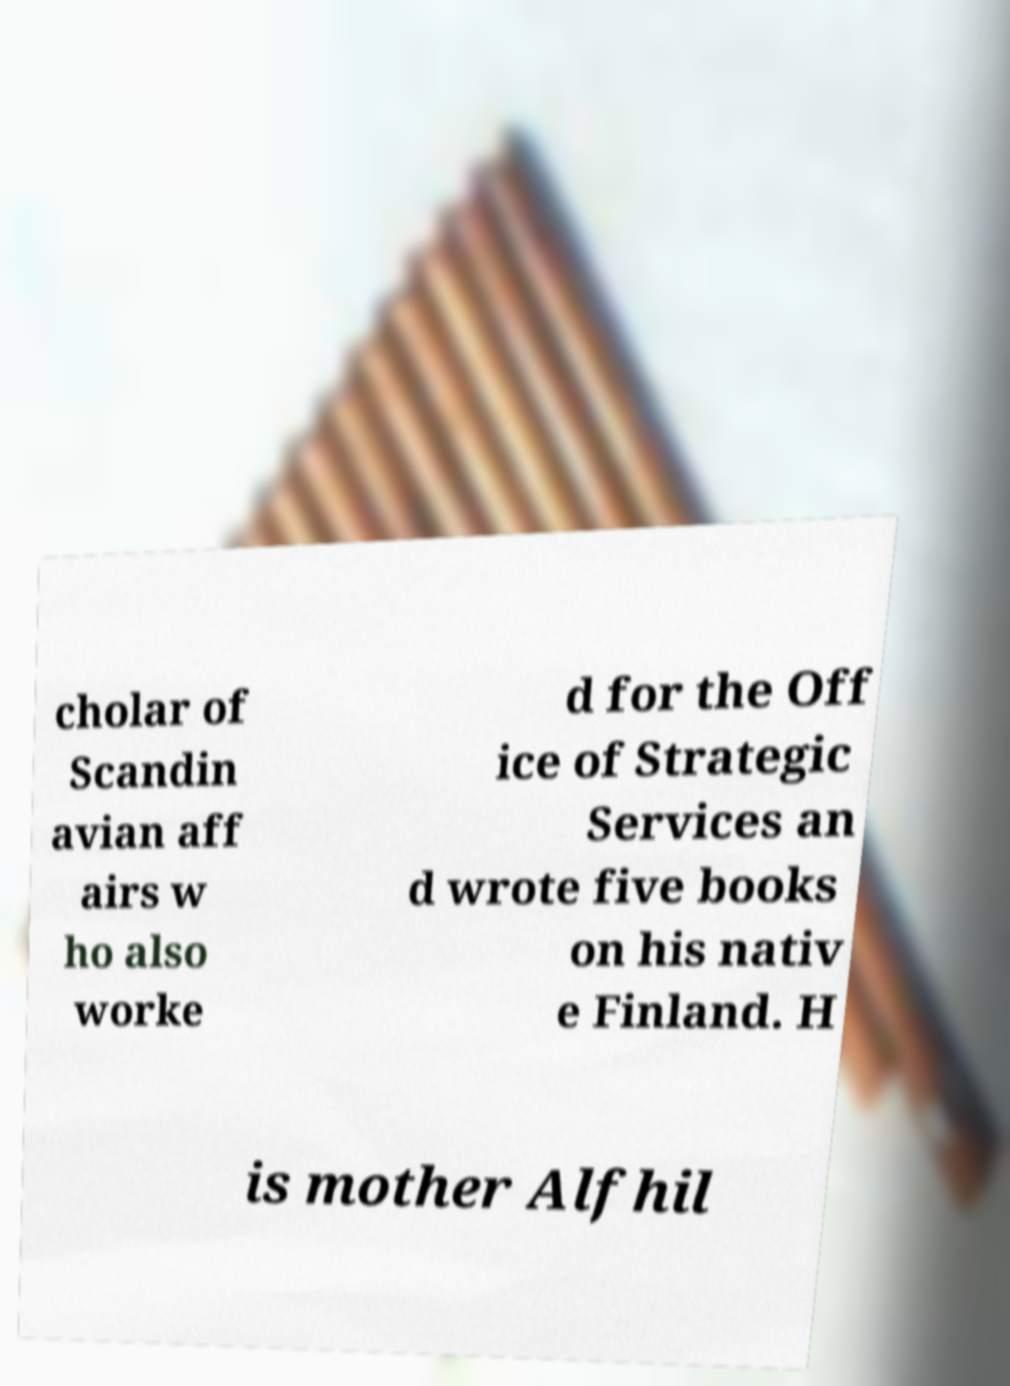Can you accurately transcribe the text from the provided image for me? cholar of Scandin avian aff airs w ho also worke d for the Off ice of Strategic Services an d wrote five books on his nativ e Finland. H is mother Alfhil 